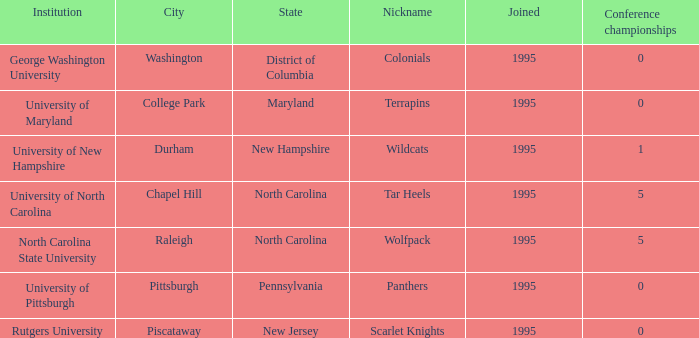At the conference championships in college park, what is the earliest year joined with a value below 0? None. 